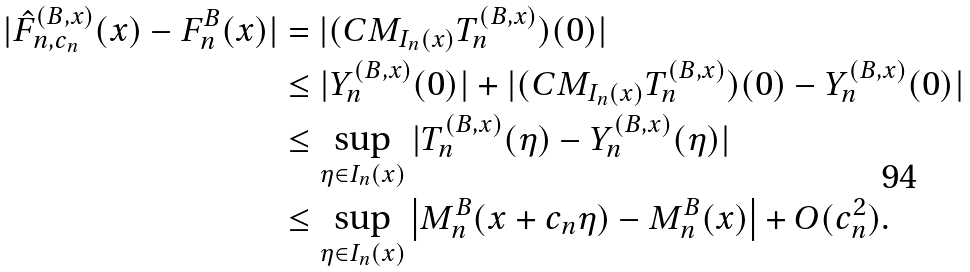<formula> <loc_0><loc_0><loc_500><loc_500>| \hat { F } _ { n , c _ { n } } ^ { ( B , x ) } ( x ) - F _ { n } ^ { B } ( x ) | & = | ( C M _ { I _ { n } ( x ) } T _ { n } ^ { ( B , x ) } ) ( 0 ) | \\ & \leq | Y _ { n } ^ { ( B , x ) } ( 0 ) | + | ( C M _ { I _ { n } ( x ) } T _ { n } ^ { ( B , x ) } ) ( 0 ) - Y _ { n } ^ { ( B , x ) } ( 0 ) | \\ & \leq \sup _ { \eta \in I _ { n } ( x ) } | T _ { n } ^ { ( B , x ) } ( \eta ) - Y _ { n } ^ { ( B , x ) } ( \eta ) | \\ & \leq \sup _ { \eta \in I _ { n } ( x ) } \left | M _ { n } ^ { B } ( x + c _ { n } \eta ) - M _ { n } ^ { B } ( x ) \right | + O ( c _ { n } ^ { 2 } ) .</formula> 